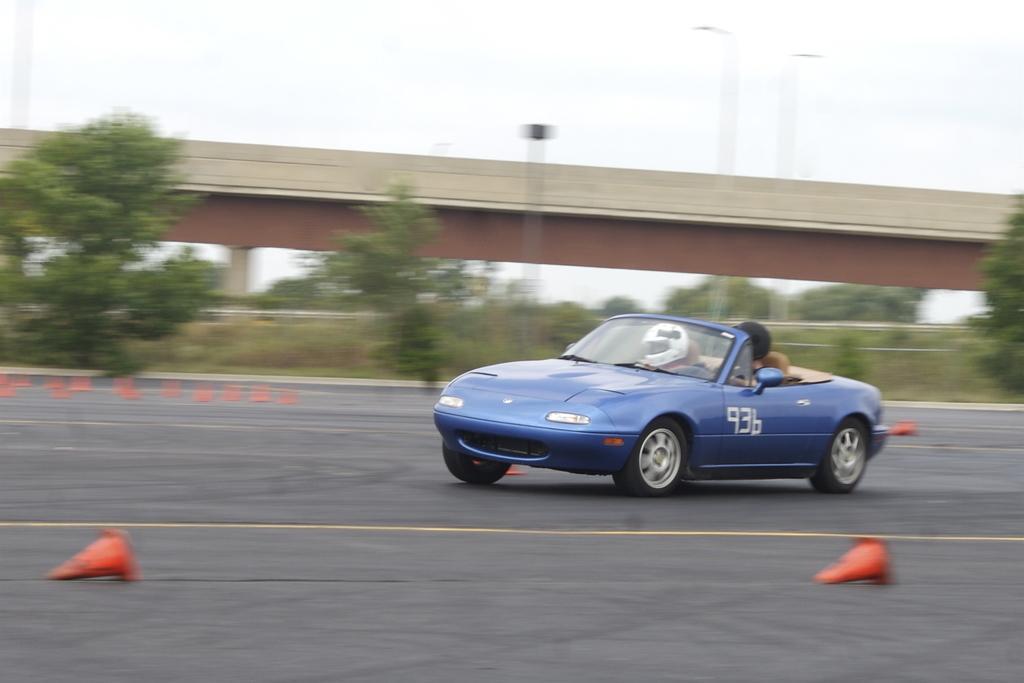Describe this image in one or two sentences. In the picture I can see one vehicle with few people are moving on the road, beside we can see some trees, grass and we can see bridge. 